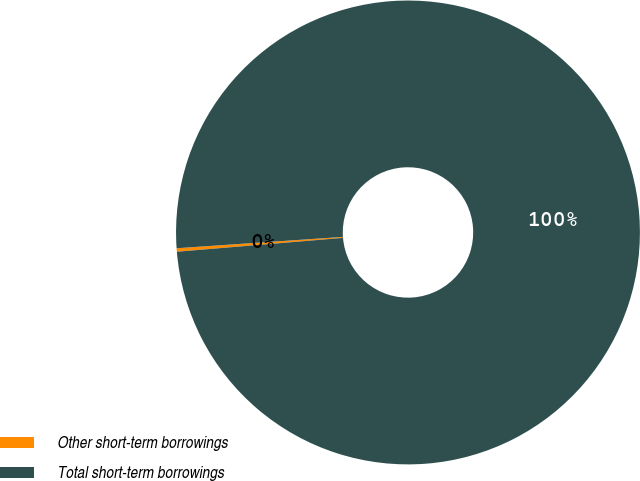Convert chart. <chart><loc_0><loc_0><loc_500><loc_500><pie_chart><fcel>Other short-term borrowings<fcel>Total short-term borrowings<nl><fcel>0.24%<fcel>99.76%<nl></chart> 